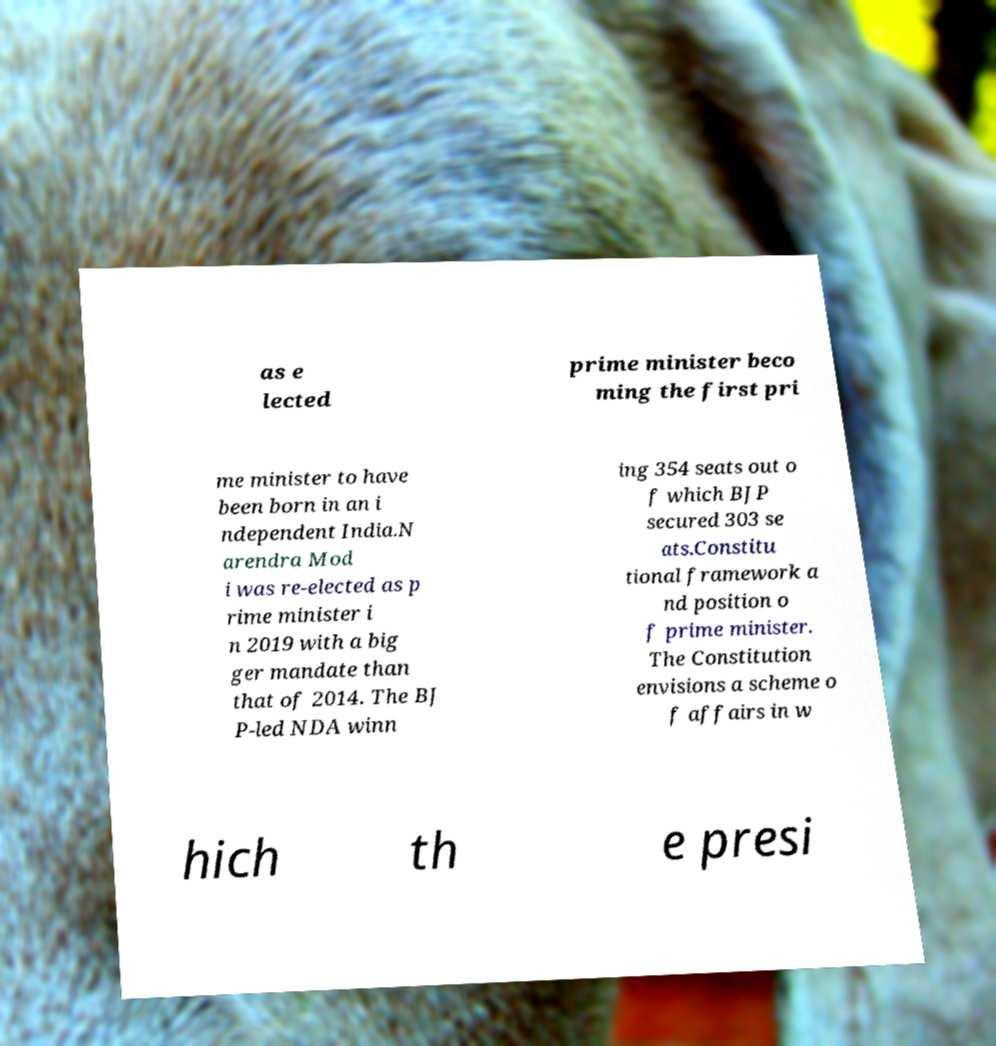Please identify and transcribe the text found in this image. as e lected prime minister beco ming the first pri me minister to have been born in an i ndependent India.N arendra Mod i was re-elected as p rime minister i n 2019 with a big ger mandate than that of 2014. The BJ P-led NDA winn ing 354 seats out o f which BJP secured 303 se ats.Constitu tional framework a nd position o f prime minister. The Constitution envisions a scheme o f affairs in w hich th e presi 